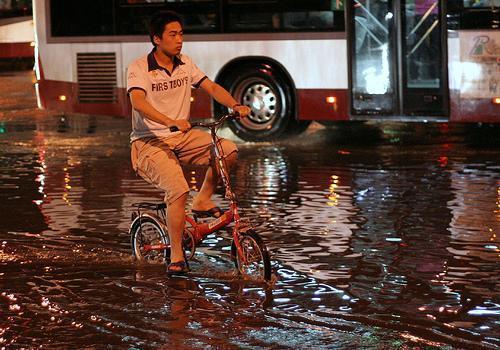How many men are riding a bike?
Give a very brief answer. 1. 